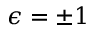Convert formula to latex. <formula><loc_0><loc_0><loc_500><loc_500>\epsilon = \pm 1</formula> 